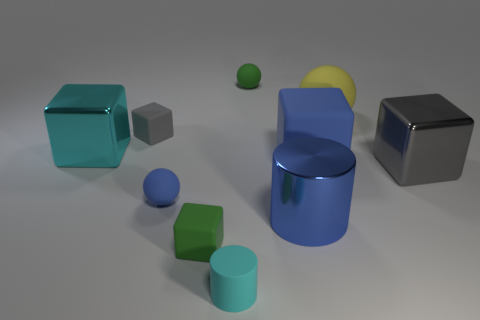Subtract all small gray cubes. How many cubes are left? 4 Subtract all blue blocks. How many blocks are left? 4 Subtract 2 blocks. How many blocks are left? 3 Subtract all yellow cubes. Subtract all blue balls. How many cubes are left? 5 Subtract all cylinders. How many objects are left? 8 Add 5 gray rubber things. How many gray rubber things are left? 6 Add 6 large green objects. How many large green objects exist? 6 Subtract 0 red cylinders. How many objects are left? 10 Subtract all large cyan cubes. Subtract all large cyan objects. How many objects are left? 8 